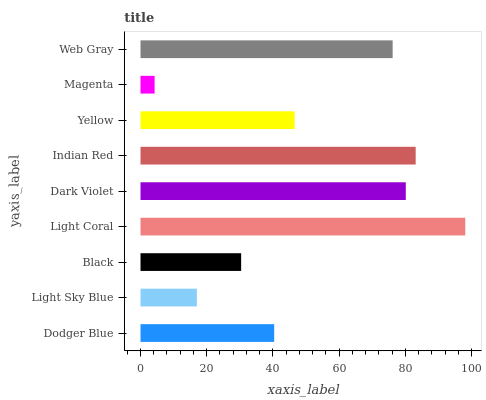Is Magenta the minimum?
Answer yes or no. Yes. Is Light Coral the maximum?
Answer yes or no. Yes. Is Light Sky Blue the minimum?
Answer yes or no. No. Is Light Sky Blue the maximum?
Answer yes or no. No. Is Dodger Blue greater than Light Sky Blue?
Answer yes or no. Yes. Is Light Sky Blue less than Dodger Blue?
Answer yes or no. Yes. Is Light Sky Blue greater than Dodger Blue?
Answer yes or no. No. Is Dodger Blue less than Light Sky Blue?
Answer yes or no. No. Is Yellow the high median?
Answer yes or no. Yes. Is Yellow the low median?
Answer yes or no. Yes. Is Dark Violet the high median?
Answer yes or no. No. Is Magenta the low median?
Answer yes or no. No. 